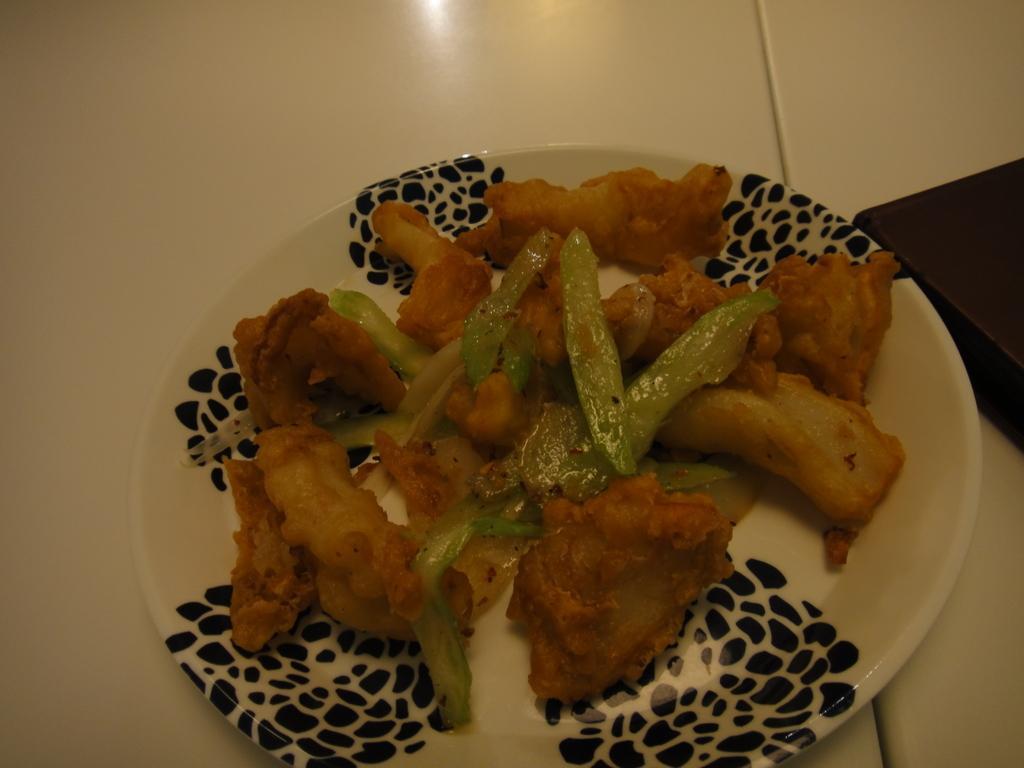Please provide a concise description of this image. In this image we can see there is the table, on the table, we can see the plate and there are some food items in it. And at the side there is the box. 